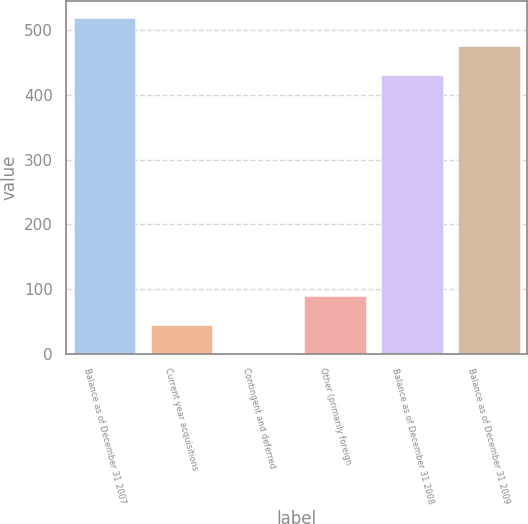Convert chart. <chart><loc_0><loc_0><loc_500><loc_500><bar_chart><fcel>Balance as of December 31 2007<fcel>Current year acquisitions<fcel>Contingent and deferred<fcel>Other (primarily foreign<fcel>Balance as of December 31 2008<fcel>Balance as of December 31 2009<nl><fcel>519.06<fcel>45.18<fcel>1.1<fcel>89.26<fcel>430.9<fcel>474.98<nl></chart> 